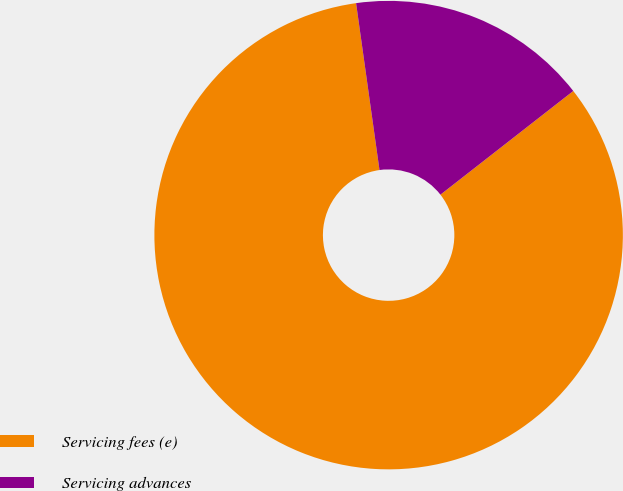Convert chart to OTSL. <chart><loc_0><loc_0><loc_500><loc_500><pie_chart><fcel>Servicing fees (e)<fcel>Servicing advances<nl><fcel>83.33%<fcel>16.67%<nl></chart> 